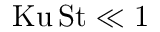Convert formula to latex. <formula><loc_0><loc_0><loc_500><loc_500>K u \, S t \ll 1</formula> 